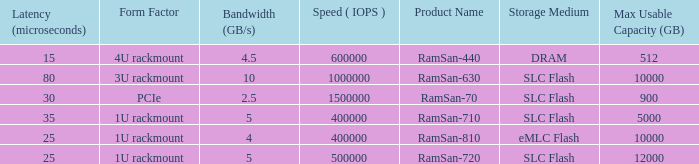List the range distroration for the ramsan-630 3U rackmount. 